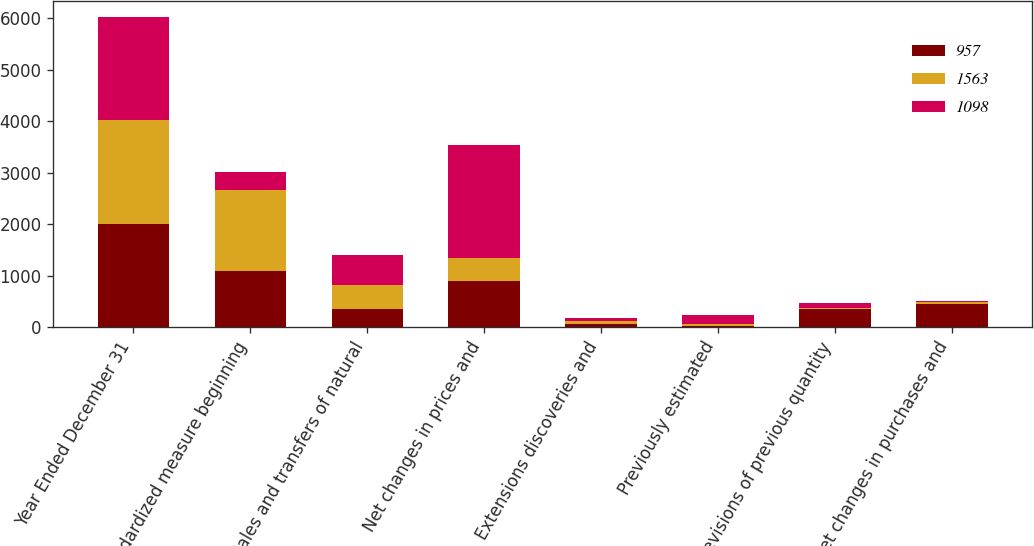Convert chart. <chart><loc_0><loc_0><loc_500><loc_500><stacked_bar_chart><ecel><fcel>Year Ended December 31<fcel>Standardized measure beginning<fcel>Sales and transfers of natural<fcel>Net changes in prices and<fcel>Extensions discoveries and<fcel>Previously estimated<fcel>Revisions of previous quantity<fcel>Net changes in purchases and<nl><fcel>957<fcel>2010<fcel>1098<fcel>345<fcel>890<fcel>67<fcel>23<fcel>346<fcel>446<nl><fcel>1563<fcel>2009<fcel>1563<fcel>466<fcel>443<fcel>46<fcel>41<fcel>19<fcel>42<nl><fcel>1098<fcel>2008<fcel>346<fcel>594<fcel>2205<fcel>69<fcel>170<fcel>94<fcel>11<nl></chart> 